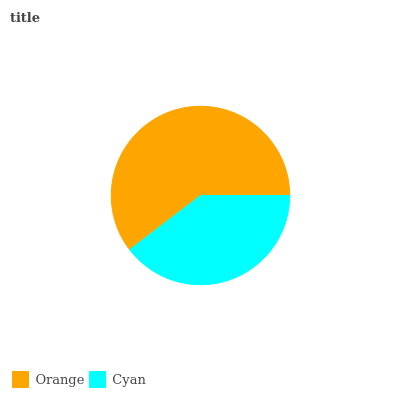Is Cyan the minimum?
Answer yes or no. Yes. Is Orange the maximum?
Answer yes or no. Yes. Is Cyan the maximum?
Answer yes or no. No. Is Orange greater than Cyan?
Answer yes or no. Yes. Is Cyan less than Orange?
Answer yes or no. Yes. Is Cyan greater than Orange?
Answer yes or no. No. Is Orange less than Cyan?
Answer yes or no. No. Is Orange the high median?
Answer yes or no. Yes. Is Cyan the low median?
Answer yes or no. Yes. Is Cyan the high median?
Answer yes or no. No. Is Orange the low median?
Answer yes or no. No. 